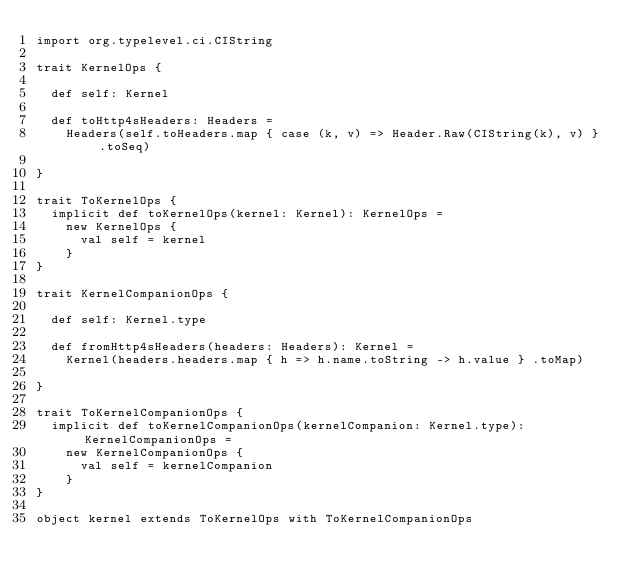<code> <loc_0><loc_0><loc_500><loc_500><_Scala_>import org.typelevel.ci.CIString

trait KernelOps {

  def self: Kernel

  def toHttp4sHeaders: Headers =
    Headers(self.toHeaders.map { case (k, v) => Header.Raw(CIString(k), v) } .toSeq)

}

trait ToKernelOps {
  implicit def toKernelOps(kernel: Kernel): KernelOps =
    new KernelOps {
      val self = kernel
    }
}

trait KernelCompanionOps {

  def self: Kernel.type

  def fromHttp4sHeaders(headers: Headers): Kernel =
    Kernel(headers.headers.map { h => h.name.toString -> h.value } .toMap)

}

trait ToKernelCompanionOps {
  implicit def toKernelCompanionOps(kernelCompanion: Kernel.type): KernelCompanionOps =
    new KernelCompanionOps {
      val self = kernelCompanion
    }
}

object kernel extends ToKernelOps with ToKernelCompanionOps
</code> 